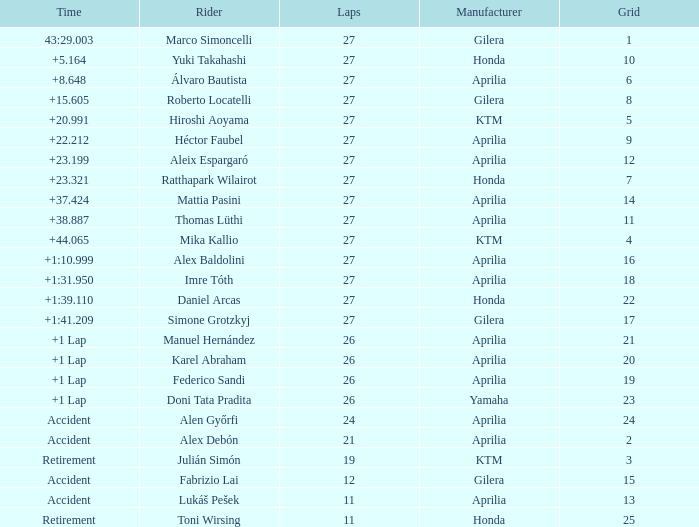Which Manufacturer has a Time of accident and a Grid greater than 15? Aprilia. Could you parse the entire table as a dict? {'header': ['Time', 'Rider', 'Laps', 'Manufacturer', 'Grid'], 'rows': [['43:29.003', 'Marco Simoncelli', '27', 'Gilera', '1'], ['+5.164', 'Yuki Takahashi', '27', 'Honda', '10'], ['+8.648', 'Álvaro Bautista', '27', 'Aprilia', '6'], ['+15.605', 'Roberto Locatelli', '27', 'Gilera', '8'], ['+20.991', 'Hiroshi Aoyama', '27', 'KTM', '5'], ['+22.212', 'Héctor Faubel', '27', 'Aprilia', '9'], ['+23.199', 'Aleix Espargaró', '27', 'Aprilia', '12'], ['+23.321', 'Ratthapark Wilairot', '27', 'Honda', '7'], ['+37.424', 'Mattia Pasini', '27', 'Aprilia', '14'], ['+38.887', 'Thomas Lüthi', '27', 'Aprilia', '11'], ['+44.065', 'Mika Kallio', '27', 'KTM', '4'], ['+1:10.999', 'Alex Baldolini', '27', 'Aprilia', '16'], ['+1:31.950', 'Imre Tóth', '27', 'Aprilia', '18'], ['+1:39.110', 'Daniel Arcas', '27', 'Honda', '22'], ['+1:41.209', 'Simone Grotzkyj', '27', 'Gilera', '17'], ['+1 Lap', 'Manuel Hernández', '26', 'Aprilia', '21'], ['+1 Lap', 'Karel Abraham', '26', 'Aprilia', '20'], ['+1 Lap', 'Federico Sandi', '26', 'Aprilia', '19'], ['+1 Lap', 'Doni Tata Pradita', '26', 'Yamaha', '23'], ['Accident', 'Alen Győrfi', '24', 'Aprilia', '24'], ['Accident', 'Alex Debón', '21', 'Aprilia', '2'], ['Retirement', 'Julián Simón', '19', 'KTM', '3'], ['Accident', 'Fabrizio Lai', '12', 'Gilera', '15'], ['Accident', 'Lukáš Pešek', '11', 'Aprilia', '13'], ['Retirement', 'Toni Wirsing', '11', 'Honda', '25']]} 